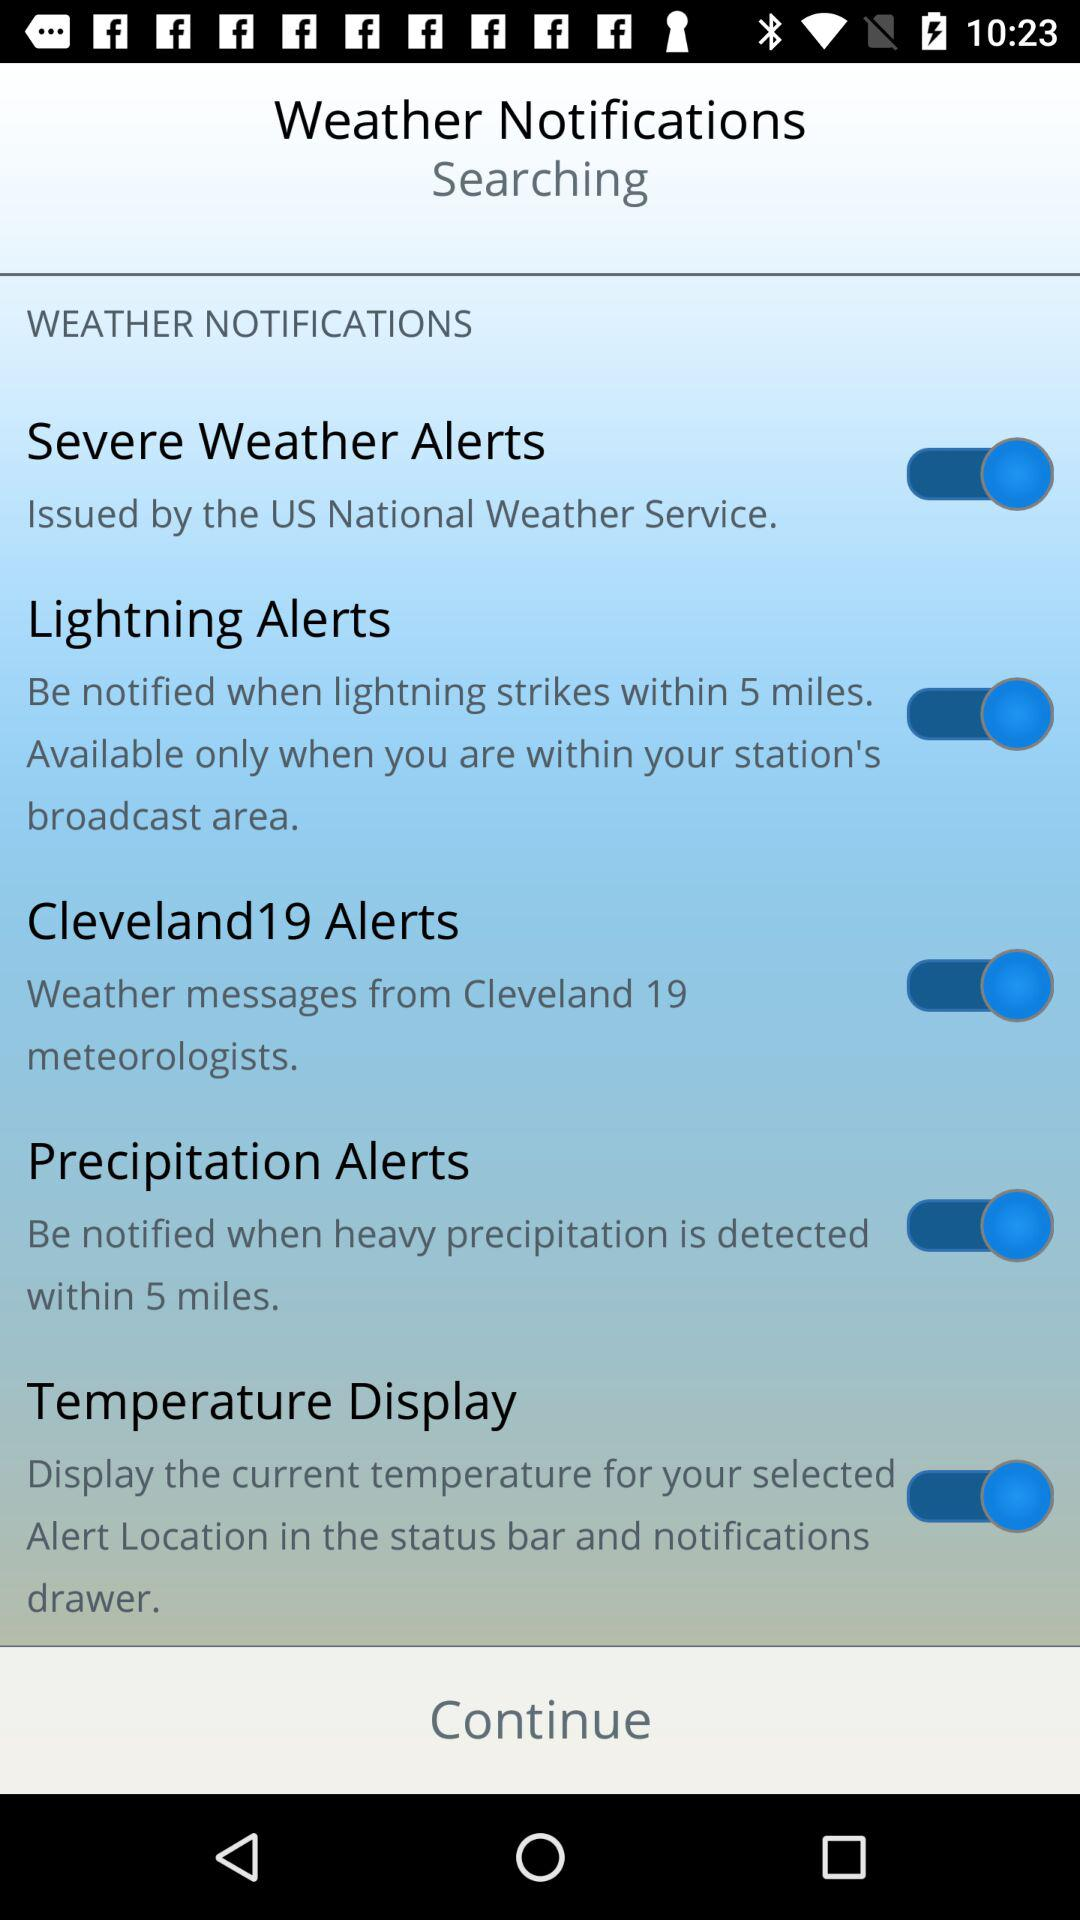What is the status of "Temperature Display"? The status is "on". 